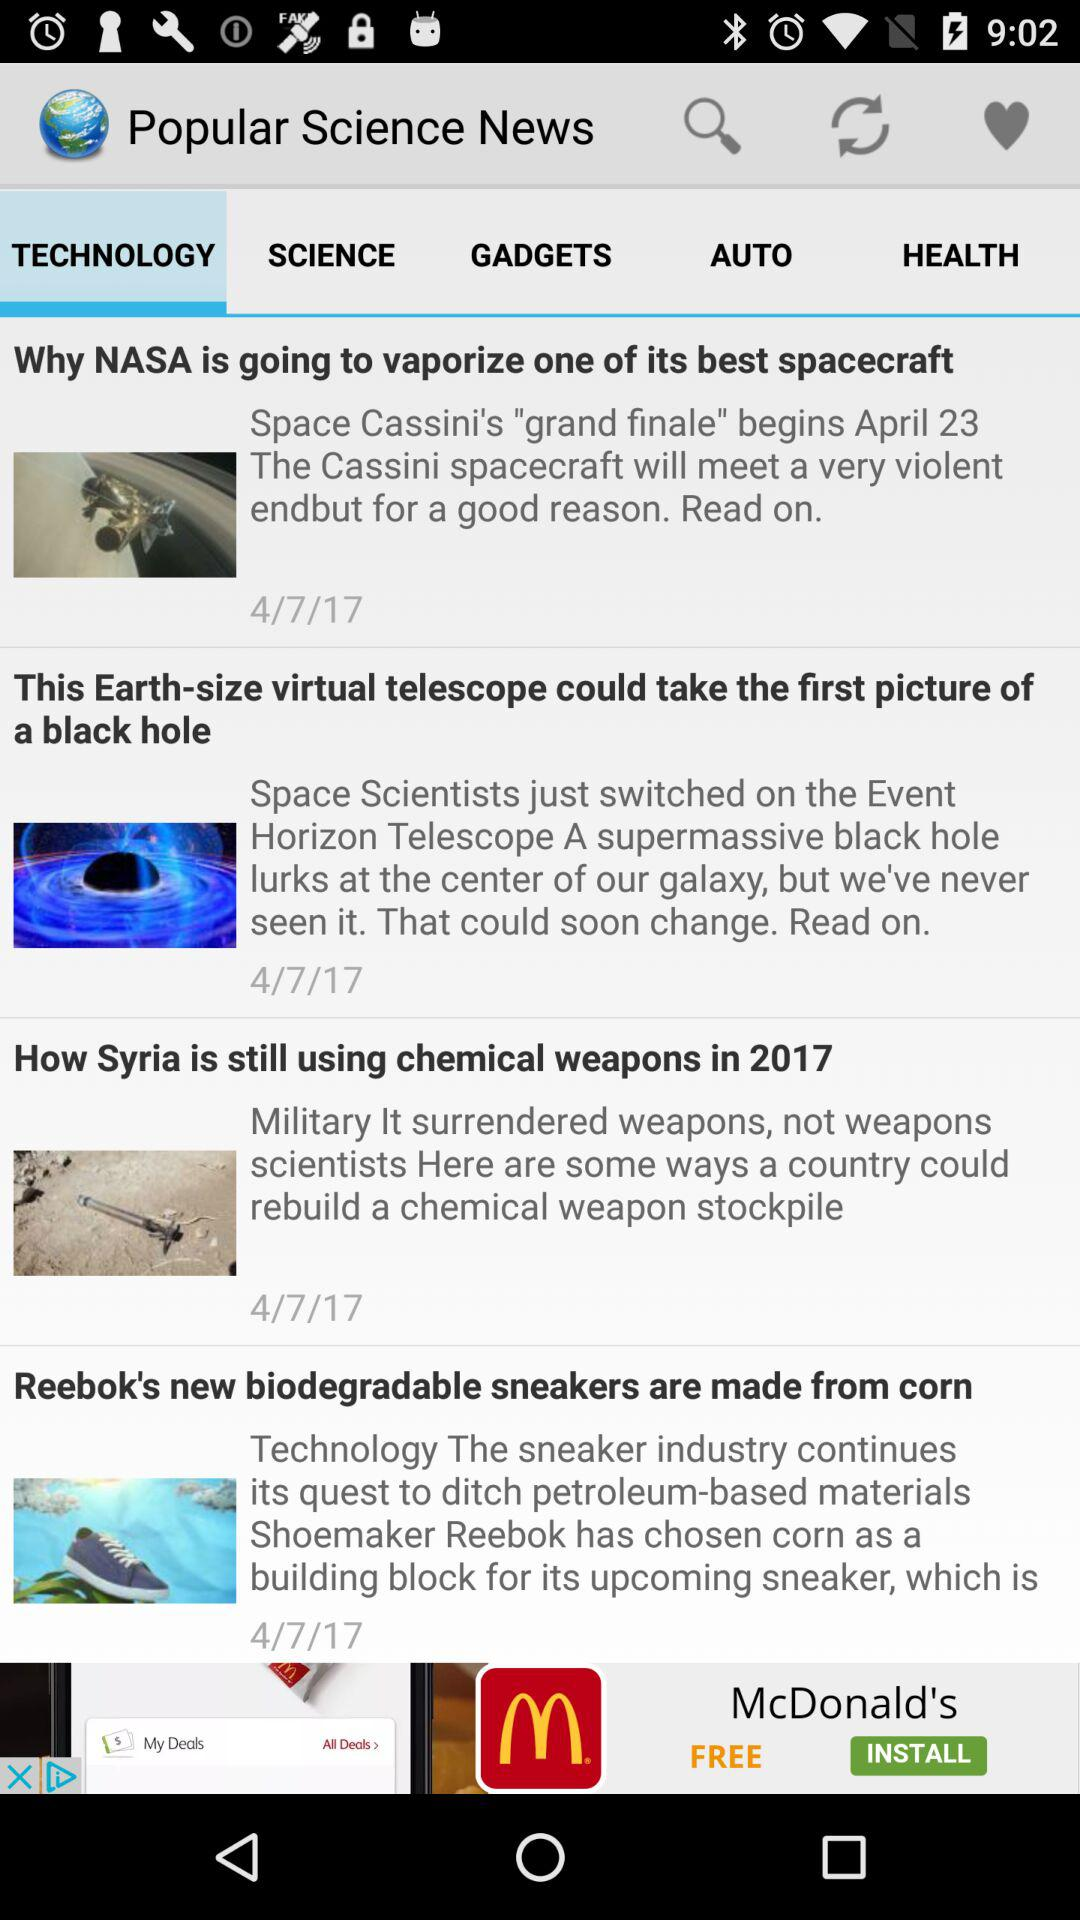What is the selected date in the news? The selected date is April 7, 2017. 